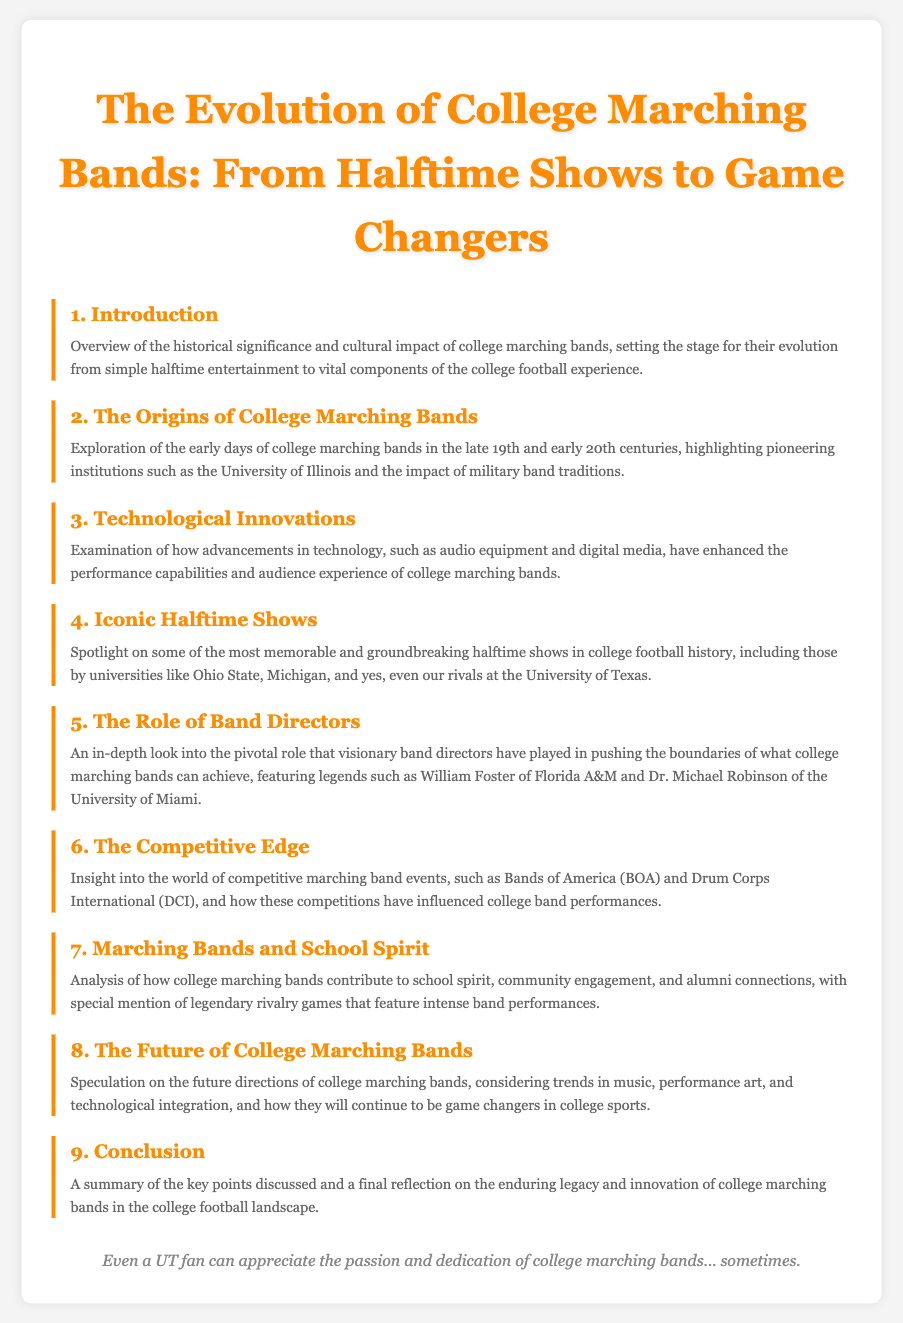What is the title of the document? The title is the main focus of the document and can be found at the top.
Answer: The Evolution of College Marching Bands: From Halftime Shows to Game Changers How many sections are in the table of contents? The sections are listed numerically and can be counted simply.
Answer: 9 Who is mentioned as a pioneering institution in the origins of college marching bands? This specific institution is highlighted in the section regarding the early days of college marching bands.
Answer: University of Illinois What role do band directors play according to the document? The section title suggests a significant contribution of band directors to college marching bands.
Answer: Pivotal role What is the focus of the section on competitive marching bands? The section discusses a specific aspect of college marching bands related to competitions.
Answer: Competitive marching band events What is speculated about the future of college marching bands? This reflects the section's content which discusses prospective trends related to college marching bands.
Answer: Future directions Which university's halftime shows are spotlighted alongside iconic shows? This university is mentioned in a context highlighting competitive and renowned performances.
Answer: University of Texas What is the key theme in the conclusion of the document? Conclusions summarize the main ideas of the document, and this theme reflects on the impact of the subject matter.
Answer: Enduring legacy What enhances the performance capabilities of college marching bands? This is discussed in the context of advancements contributing to marching bands.
Answer: Technological innovations 